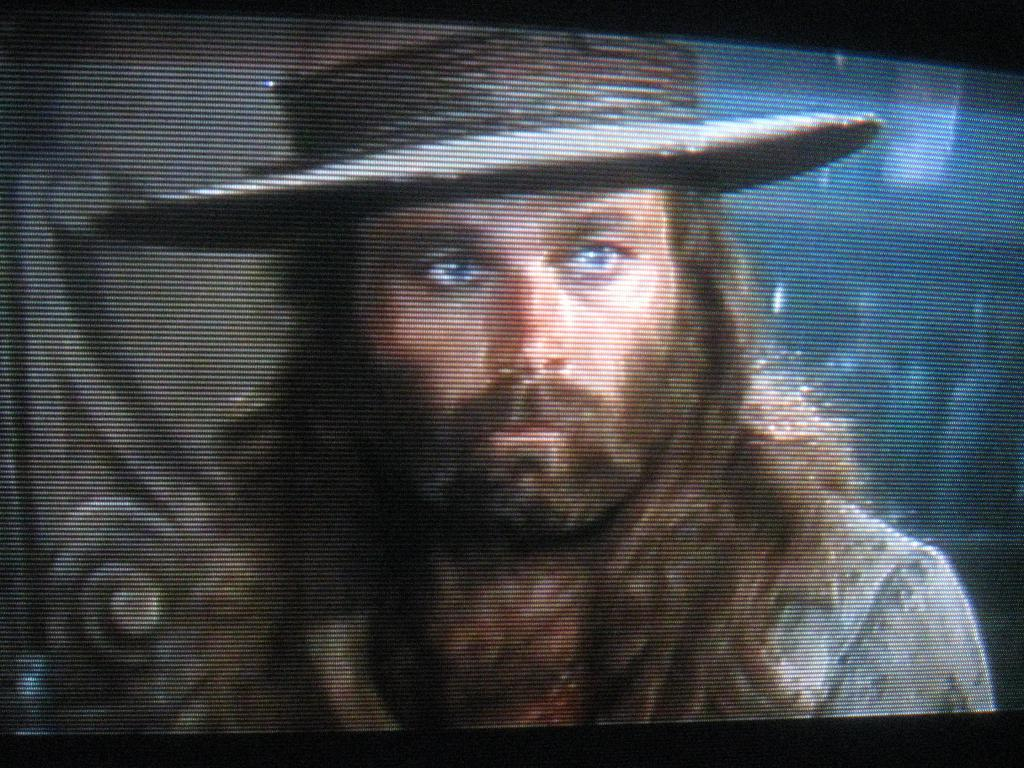What is the main object in the image? There is a screen in the image. What can be seen on the screen? The screen displays an image of a man. Can you describe the man's appearance? The man is wearing a hat, has a beard, and has a mustache. How many stamps does the man have on his hat in the image? There are no stamps visible on the man's hat in the image. What type of ring is the man wearing on his finger in the image? There is no ring visible on the man's finger in the image. 